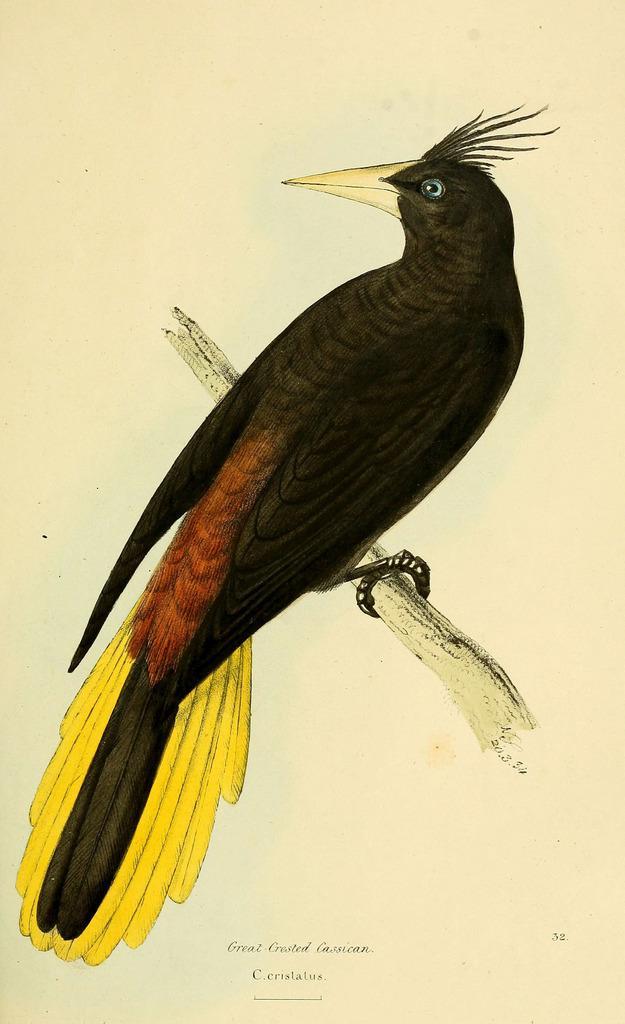Describe this image in one or two sentences. This image contains a painting. A bird is on the wooden trunk. Bottom of the image there is some text. 